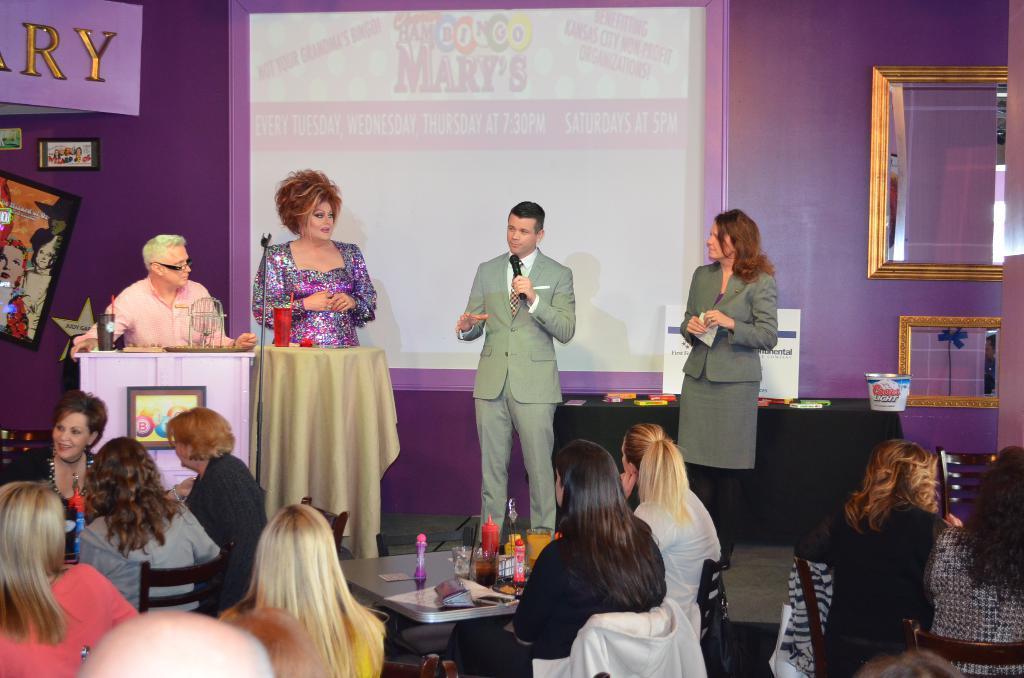Please provide a concise description of this image. In this picture we can see some people sitting on chairs in front of tables, there are four persons standing here, a man in the middle is holding a microphone, in the background we can see a wall, there is a photo frame here, we can see a projector screen here, there is a cloth here. 